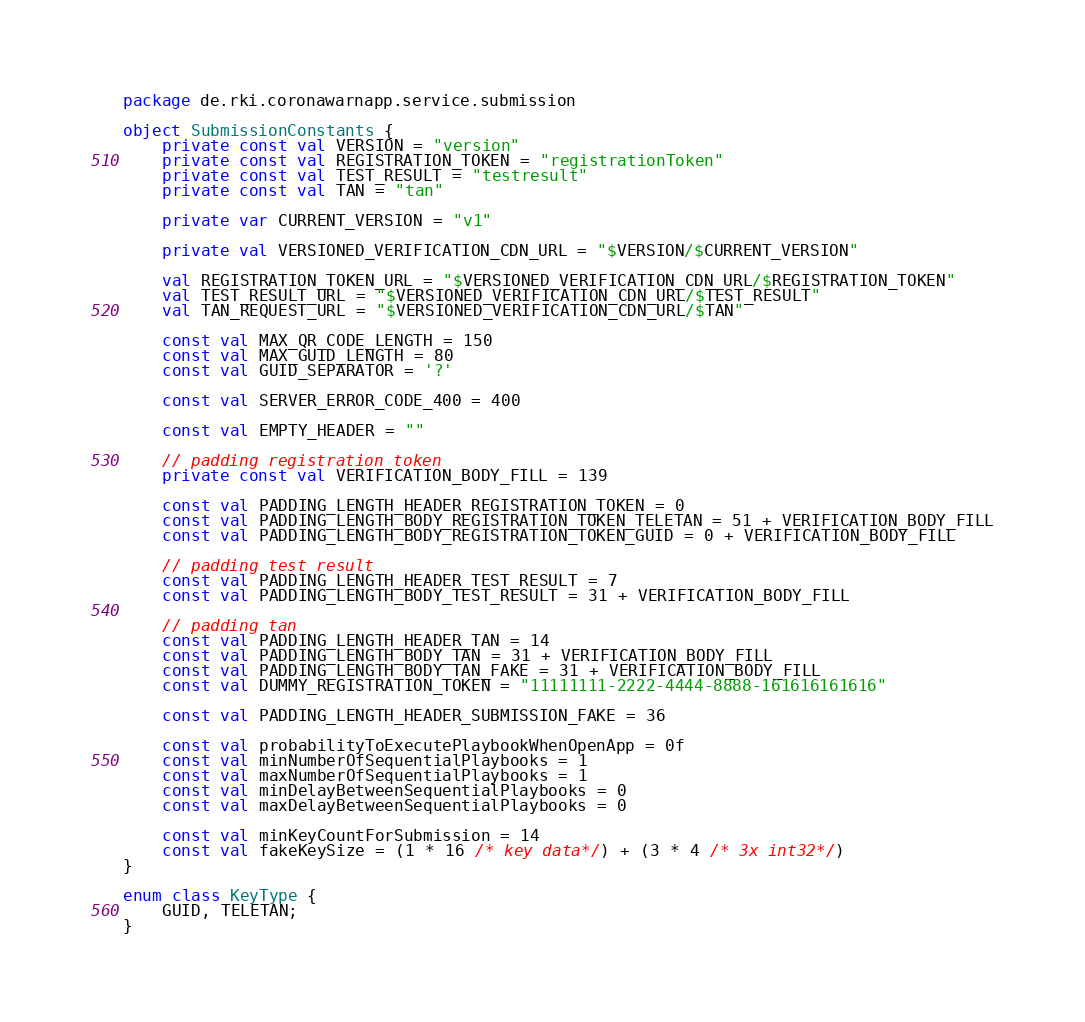Convert code to text. <code><loc_0><loc_0><loc_500><loc_500><_Kotlin_>package de.rki.coronawarnapp.service.submission

object SubmissionConstants {
    private const val VERSION = "version"
    private const val REGISTRATION_TOKEN = "registrationToken"
    private const val TEST_RESULT = "testresult"
    private const val TAN = "tan"

    private var CURRENT_VERSION = "v1"

    private val VERSIONED_VERIFICATION_CDN_URL = "$VERSION/$CURRENT_VERSION"

    val REGISTRATION_TOKEN_URL = "$VERSIONED_VERIFICATION_CDN_URL/$REGISTRATION_TOKEN"
    val TEST_RESULT_URL = "$VERSIONED_VERIFICATION_CDN_URL/$TEST_RESULT"
    val TAN_REQUEST_URL = "$VERSIONED_VERIFICATION_CDN_URL/$TAN"

    const val MAX_QR_CODE_LENGTH = 150
    const val MAX_GUID_LENGTH = 80
    const val GUID_SEPARATOR = '?'

    const val SERVER_ERROR_CODE_400 = 400

    const val EMPTY_HEADER = ""

    // padding registration token
    private const val VERIFICATION_BODY_FILL = 139

    const val PADDING_LENGTH_HEADER_REGISTRATION_TOKEN = 0
    const val PADDING_LENGTH_BODY_REGISTRATION_TOKEN_TELETAN = 51 + VERIFICATION_BODY_FILL
    const val PADDING_LENGTH_BODY_REGISTRATION_TOKEN_GUID = 0 + VERIFICATION_BODY_FILL

    // padding test result
    const val PADDING_LENGTH_HEADER_TEST_RESULT = 7
    const val PADDING_LENGTH_BODY_TEST_RESULT = 31 + VERIFICATION_BODY_FILL

    // padding tan
    const val PADDING_LENGTH_HEADER_TAN = 14
    const val PADDING_LENGTH_BODY_TAN = 31 + VERIFICATION_BODY_FILL
    const val PADDING_LENGTH_BODY_TAN_FAKE = 31 + VERIFICATION_BODY_FILL
    const val DUMMY_REGISTRATION_TOKEN = "11111111-2222-4444-8888-161616161616"

    const val PADDING_LENGTH_HEADER_SUBMISSION_FAKE = 36

    const val probabilityToExecutePlaybookWhenOpenApp = 0f
    const val minNumberOfSequentialPlaybooks = 1
    const val maxNumberOfSequentialPlaybooks = 1
    const val minDelayBetweenSequentialPlaybooks = 0
    const val maxDelayBetweenSequentialPlaybooks = 0

    const val minKeyCountForSubmission = 14
    const val fakeKeySize = (1 * 16 /* key data*/) + (3 * 4 /* 3x int32*/)
}

enum class KeyType {
    GUID, TELETAN;
}
</code> 